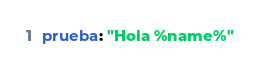<code> <loc_0><loc_0><loc_500><loc_500><_YAML_>prueba: "Hola %name%"</code> 